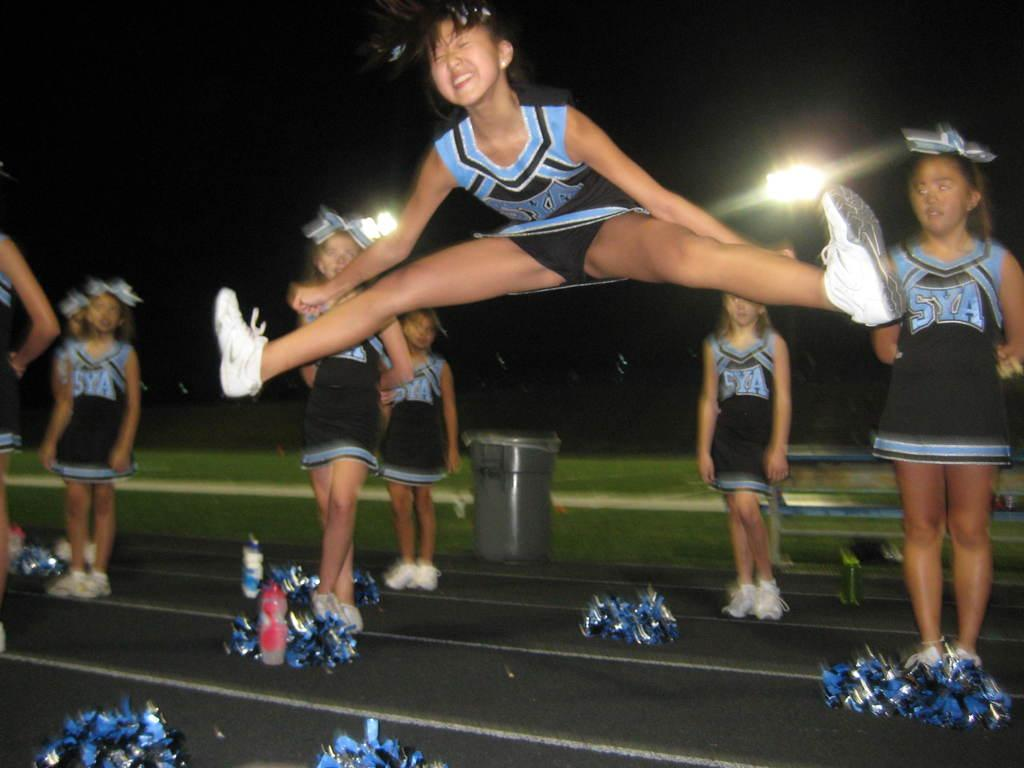Provide a one-sentence caption for the provided image. A SYA cheerleader does an air split in front of her squad. 